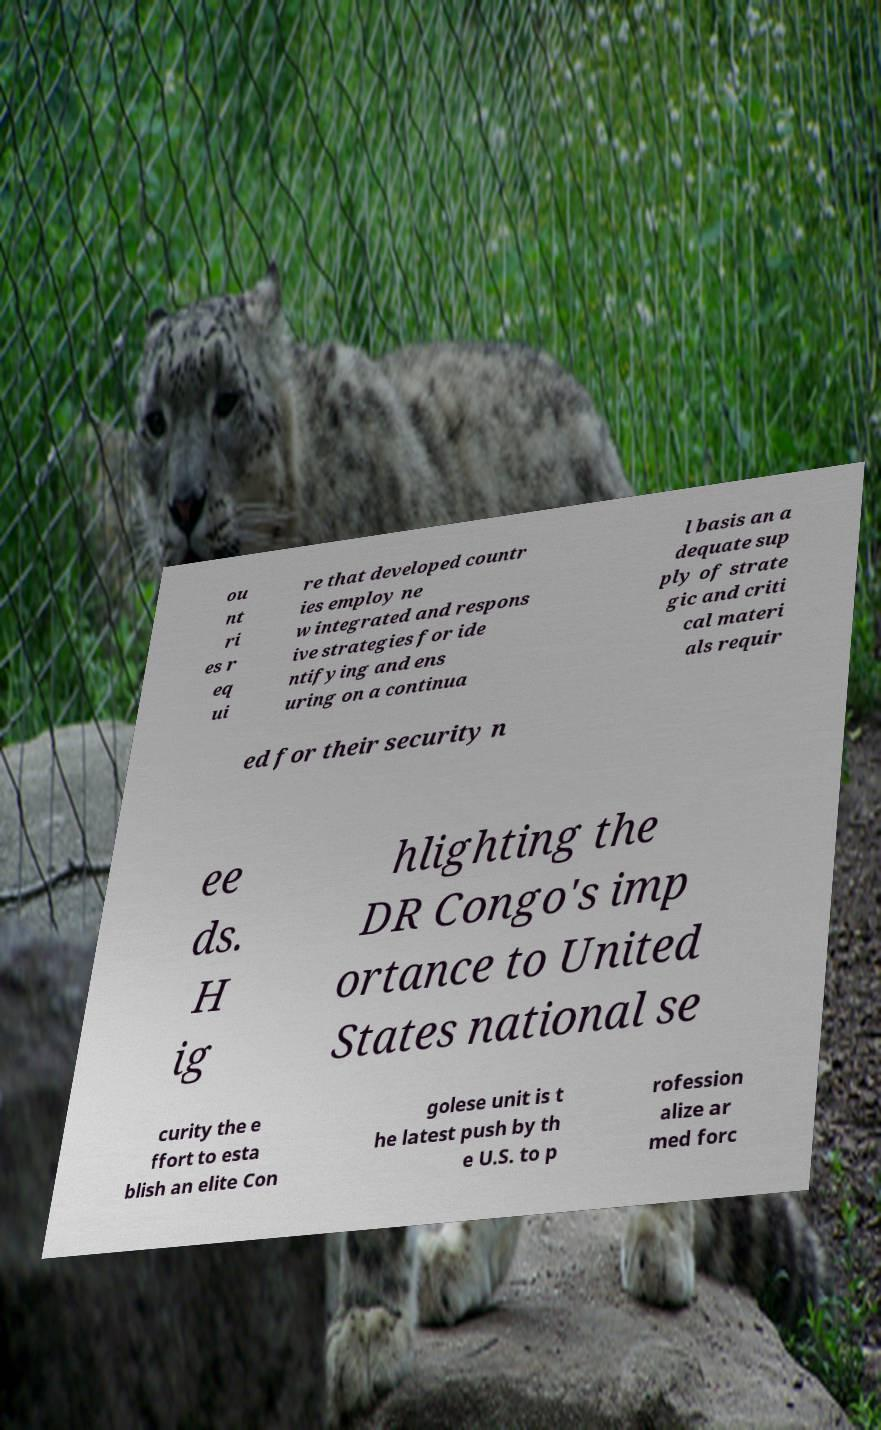Could you assist in decoding the text presented in this image and type it out clearly? ou nt ri es r eq ui re that developed countr ies employ ne w integrated and respons ive strategies for ide ntifying and ens uring on a continua l basis an a dequate sup ply of strate gic and criti cal materi als requir ed for their security n ee ds. H ig hlighting the DR Congo's imp ortance to United States national se curity the e ffort to esta blish an elite Con golese unit is t he latest push by th e U.S. to p rofession alize ar med forc 